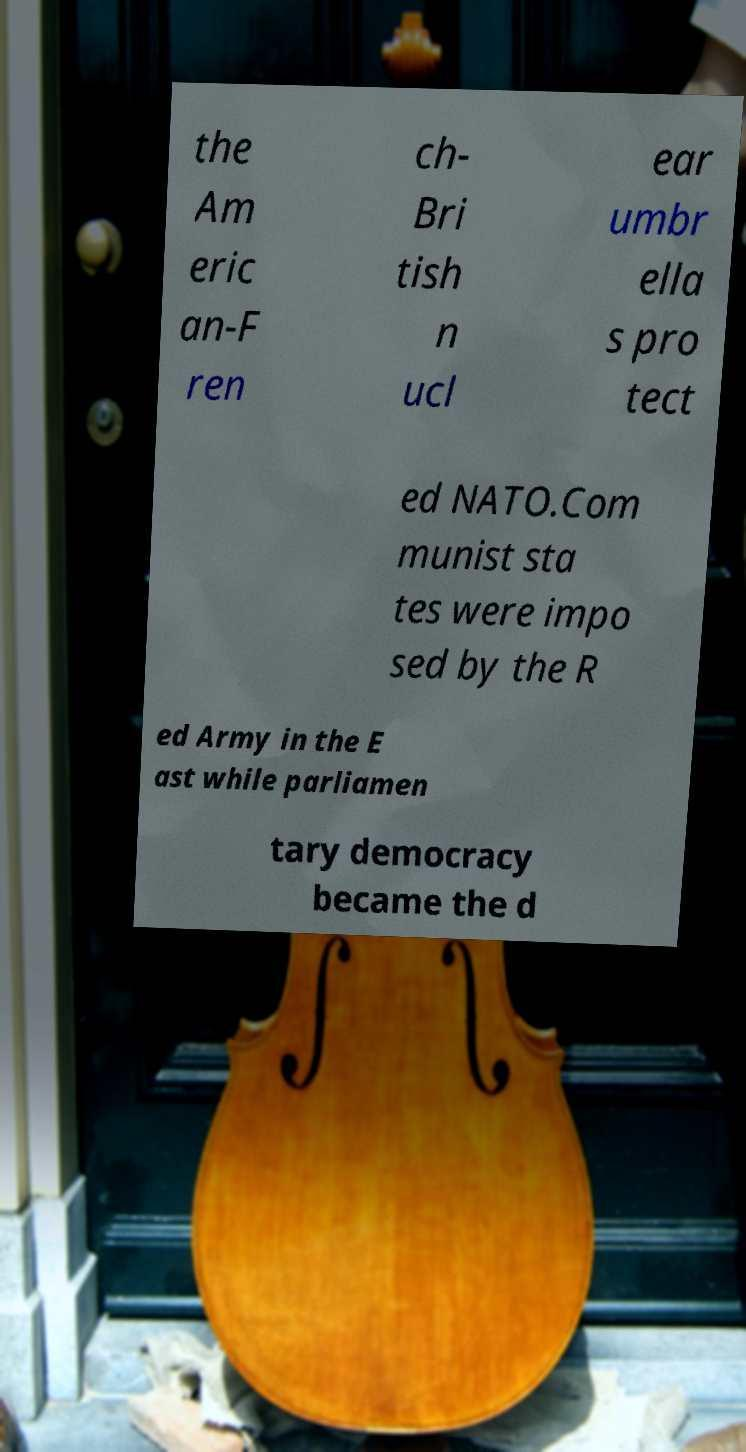For documentation purposes, I need the text within this image transcribed. Could you provide that? the Am eric an-F ren ch- Bri tish n ucl ear umbr ella s pro tect ed NATO.Com munist sta tes were impo sed by the R ed Army in the E ast while parliamen tary democracy became the d 